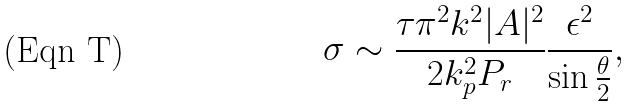Convert formula to latex. <formula><loc_0><loc_0><loc_500><loc_500>\sigma \sim \frac { \tau \pi ^ { 2 } k ^ { 2 } | A | ^ { 2 } } { 2 k _ { p } ^ { 2 } P _ { r } } \frac { \epsilon ^ { 2 } } { \sin \frac { \theta } { 2 } } ,</formula> 